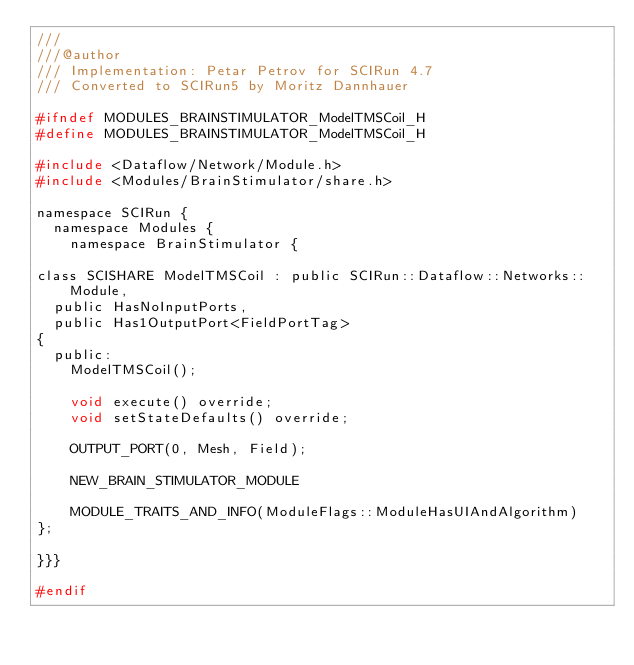<code> <loc_0><loc_0><loc_500><loc_500><_C_>///
///@author
/// Implementation: Petar Petrov for SCIRun 4.7
/// Converted to SCIRun5 by Moritz Dannhauer

#ifndef MODULES_BRAINSTIMULATOR_ModelTMSCoil_H
#define MODULES_BRAINSTIMULATOR_ModelTMSCoil_H

#include <Dataflow/Network/Module.h>
#include <Modules/BrainStimulator/share.h>

namespace SCIRun {
  namespace Modules {
    namespace BrainStimulator {

class SCISHARE ModelTMSCoil : public SCIRun::Dataflow::Networks::Module,
  public HasNoInputPorts,
  public Has1OutputPort<FieldPortTag>
{
  public:
    ModelTMSCoil();

    void execute() override;
    void setStateDefaults() override;

    OUTPUT_PORT(0, Mesh, Field);

    NEW_BRAIN_STIMULATOR_MODULE

    MODULE_TRAITS_AND_INFO(ModuleFlags::ModuleHasUIAndAlgorithm)
};

}}}

#endif
</code> 